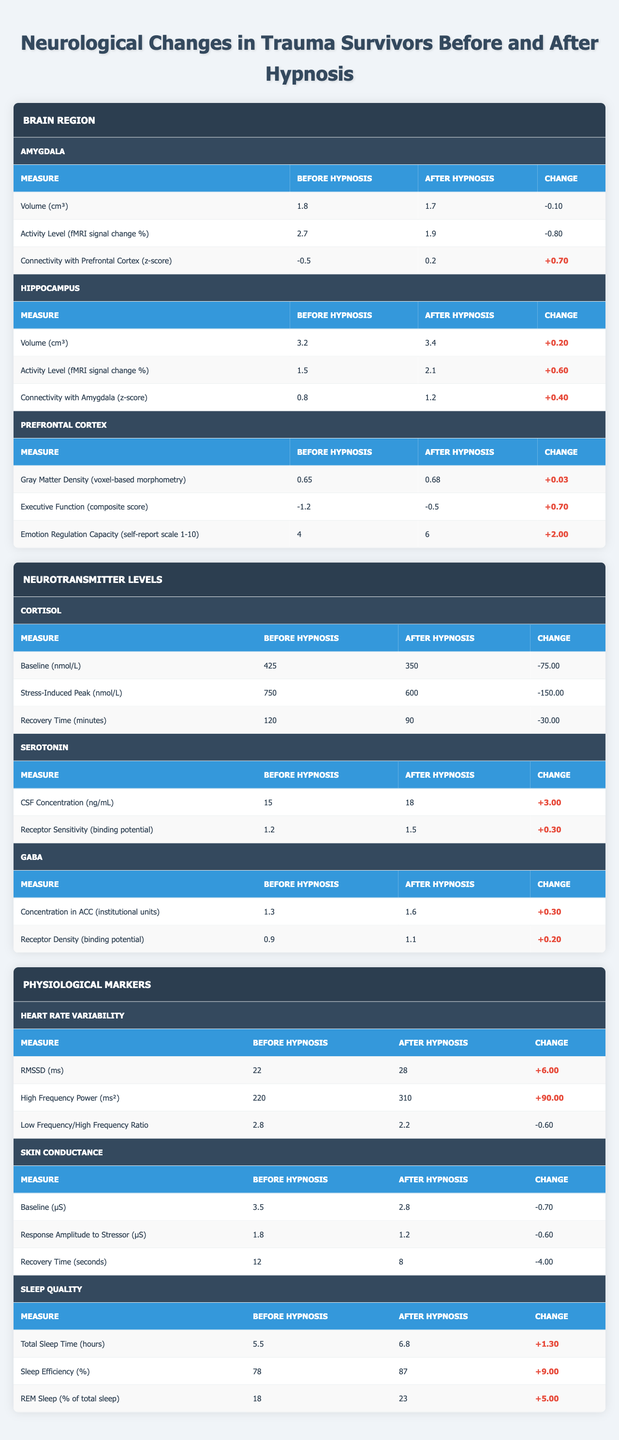What was the volume of the amygdala before hypnosis? According to the table, the volume of the amygdala before hypnosis is listed as 1.8 cm³.
Answer: 1.8 cm³ What was the activity level of the hippocampus after hypnosis? The table shows that the activity level of the hippocampus after hypnosis was measured at 2.1 fMRI signal change %.
Answer: 2.1 fMRI signal change % Did the serotonin levels increase after hypnosis? The CSF concentration of serotonin before hypnosis was 15 ng/mL, and after hypnosis, it increased to 18 ng/mL, confirming an increase.
Answer: Yes What is the difference in recovery time for cortisol levels before and after hypnosis? The recovery time for cortisol was 120 minutes before hypnosis and reduced to 90 minutes after hypnosis. The difference is 120 - 90 = 30 minutes.
Answer: 30 minutes What is the change in gray matter density in the prefrontal cortex after hypnosis? Before hypnosis, the gray matter density was 0.65, and it increased to 0.68 after hypnosis. Thus, the change is 0.68 - 0.65 = 0.03.
Answer: 0.03 Which region showed an increase in connectivity with the amygdala after hypnosis? The table indicates that the hippocampus had a connectivity with the amygdala z-score increase from 0.8 before hypnosis to 1.2 after hypnosis.
Answer: Hippocampus Is there a decrease in heart rate variability from before to after hypnosis? The RMSSD for heart rate variability increased from 22 ms before hypnosis to 28 ms after hypnosis, indicating no decrease.
Answer: No What is the average sleep efficiency percentage before and after hypnosis? Sleep efficiency was 78% before hypnosis and 87% after hypnosis. The average is (78 + 87) / 2 = 82.5%.
Answer: 82.5% What is the total change in baseline levels of cortisol before and after hypnosis? Before hypnosis, the baseline cortisol level was 425 nmol/L, and it decreased to 350 nmol/L after hypnosis, resulting in a change of 425 - 350 = 75 nmol/L.
Answer: 75 nmol/L Did the low frequency/high frequency ratio increase after hypnosis? The low frequency/high frequency ratio was 2.8 before hypnosis and decreased to 2.2 after hypnosis, indicating a decrease rather than an increase.
Answer: No 